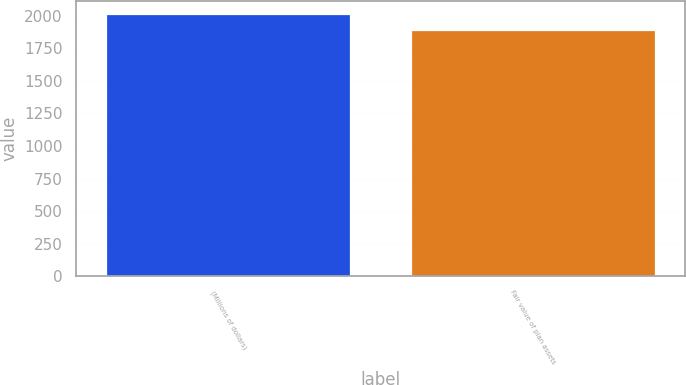Convert chart. <chart><loc_0><loc_0><loc_500><loc_500><bar_chart><fcel>(Millions of dollars)<fcel>Fair value of plan assets<nl><fcel>2017<fcel>1889<nl></chart> 